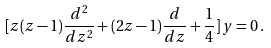Convert formula to latex. <formula><loc_0><loc_0><loc_500><loc_500>[ z ( z - 1 ) \frac { d ^ { 2 } } { d z ^ { 2 } } + ( 2 z - 1 ) \frac { d } { d z } + \frac { 1 } { 4 } ] \, y = 0 \, .</formula> 